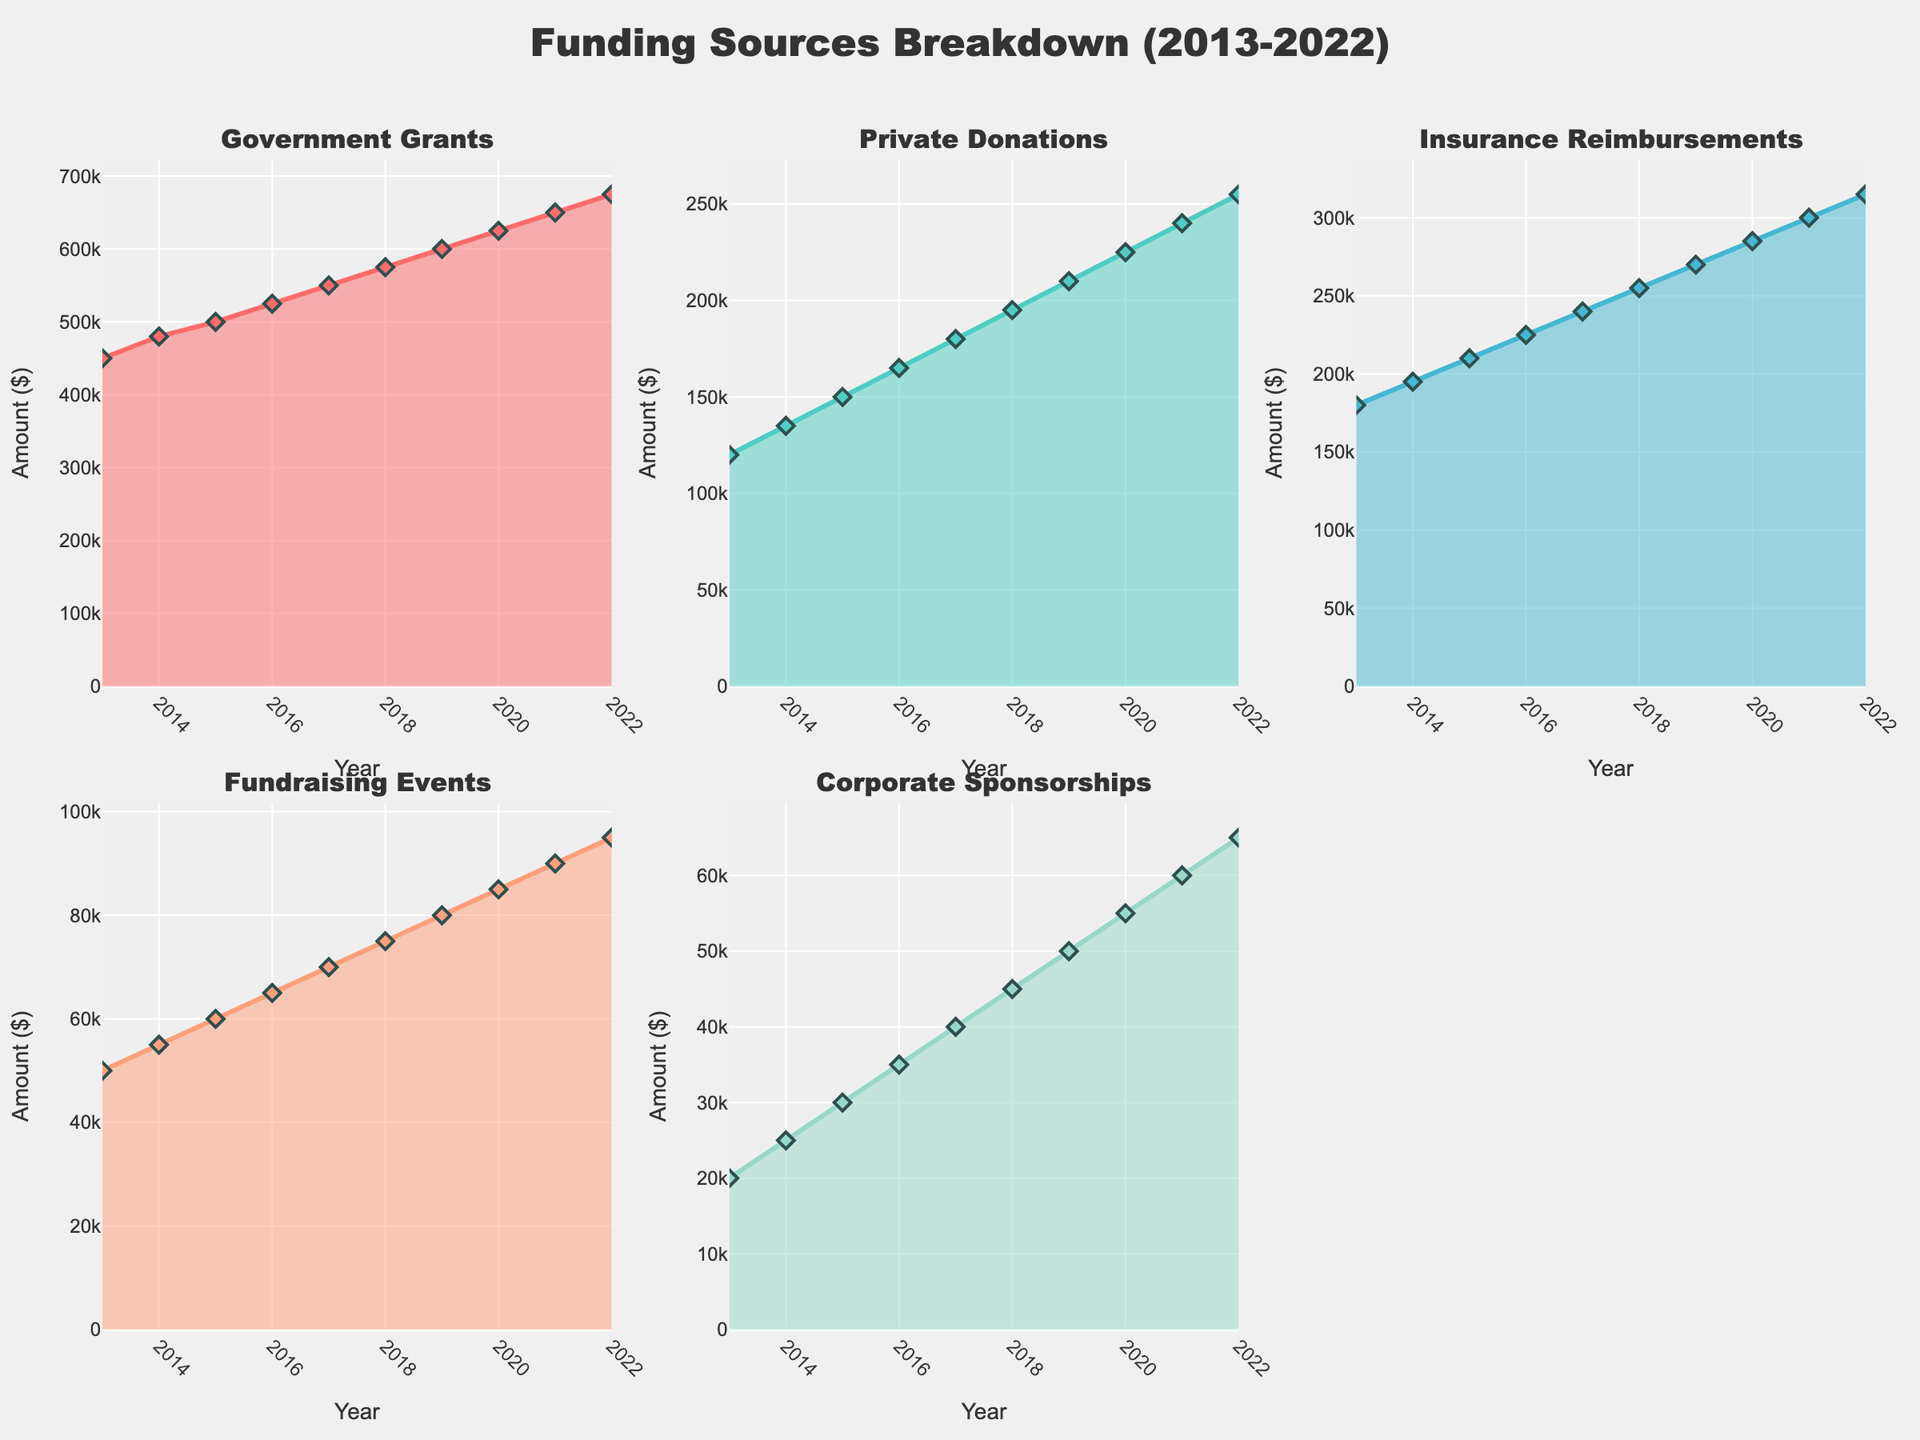What is the overall title of the figure? The title of the figure is prominently displayed at the top. It reads "Access to Healthcare Services in South Asian Countries".
Answer: Access to Healthcare Services in South Asian Countries How do 'Primary Health Centers' in rural areas compare across all countries? Rural areas have lower numbers for 'Primary Health Centers' across all countries compared to their urban counterparts. For instance, India has 42, Bangladesh 35, Pakistan 30, Nepal 28, Sri Lanka 48, and Bhutan 40.
Answer: Lower in rural areas for all countries Which country has the highest number of 'Mobile Medical Units' in rural areas? By looking at the subplot for 'Mobile Medical Units', the rural bar with the highest value appears in Sri Lanka, with a number of 62 units.
Answer: Sri Lanka Compare the number of 'District Hospitals' in urban areas between Bangladesh and Pakistan. In the subplot for 'District Hospitals', the bars for urban areas show that Bangladesh has 55 and Pakistan has 58, making Pakistan slightly higher.
Answer: Pakistan What is the difference in the number of 'Specialized Clinics' between urban and rural areas in India? In the subplot for 'Specialized Clinics', India shows 78 for urban areas and 12 for rural areas. The difference is 78 - 12.
Answer: 66 What is the average number of 'Mobile Medical Units' in rural areas for all five countries? For rural areas: India (58), Bangladesh (52), Pakistan (48), Nepal (50), Sri Lanka (62), and Bhutan (55). Sum them up (58 + 52 + 48 + 50 + 62 + 55) = 325, and divide by 5.
Answer: 65 Which area, urban or rural, has more balanced access to different types of medical facilities across the countries? Urban areas generally have more balanced access to different types of medical facilities, as seen by similarly high bars across different subplots. For rural areas, the access is more varied, particularly with lower numbers in Primary Health Centers and Specialized Clinics.
Answer: Urban areas Among the countries, where is the discrepancy between urban and rural most prominent in terms of 'Primary Health Centers'? In the subplot for 'Primary Health Centers', India shows a large discrepancy: Urban has 85 and Rural has 42, which is the most prominent difference among the countries.
Answer: India Do 'Specialized Clinics' in urban areas exceed 50 in all countries? Checking the subplot for 'Specialized Clinics' in urban areas, the lowest number is in Nepal, which has 55, so yes, all countries exceed 50.
Answer: Yes What can be inferred about the state of healthcare facilities in rural vs. urban areas from this figure? Urban areas across the countries generally have better access to healthcare facilities in terms of numbers, with consistently higher values for each type of medical facility compared to rural areas.
Answer: Urban areas have better access 